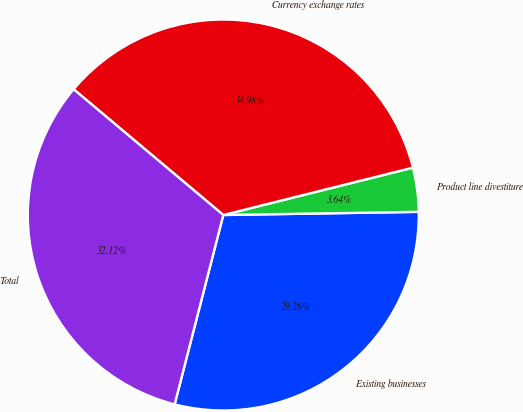Convert chart. <chart><loc_0><loc_0><loc_500><loc_500><pie_chart><fcel>Existing businesses<fcel>Product line divestiture<fcel>Currency exchange rates<fcel>Total<nl><fcel>29.26%<fcel>3.64%<fcel>34.98%<fcel>32.12%<nl></chart> 